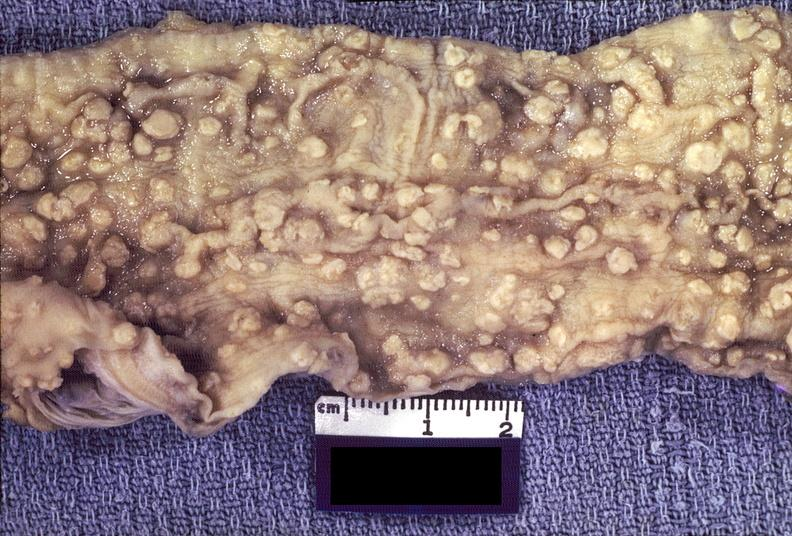does this image show colon, amebic colitis?
Answer the question using a single word or phrase. Yes 